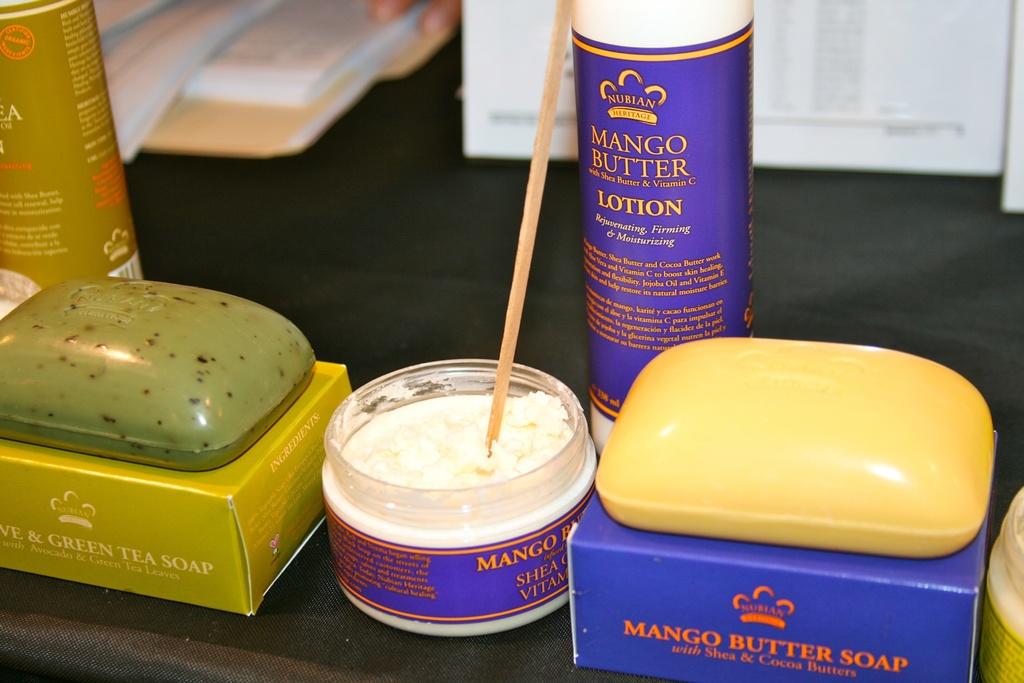What flavor is the soap and lotion?
Your answer should be compact. Mango butter. 